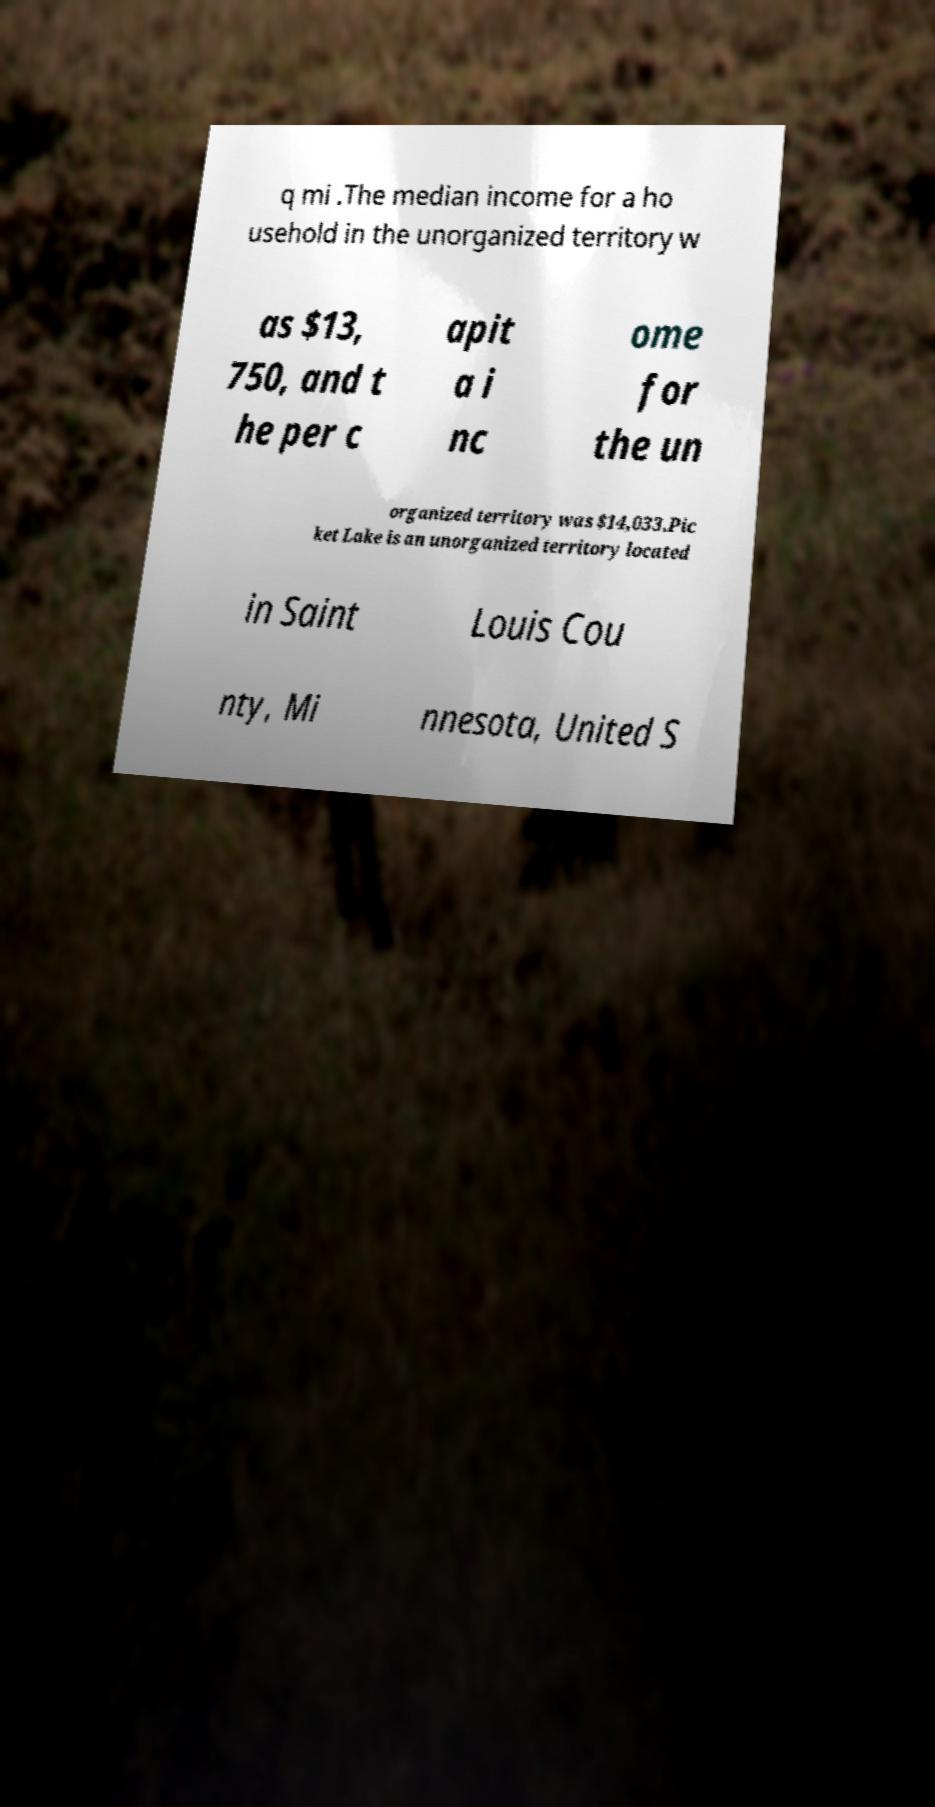I need the written content from this picture converted into text. Can you do that? q mi .The median income for a ho usehold in the unorganized territory w as $13, 750, and t he per c apit a i nc ome for the un organized territory was $14,033.Pic ket Lake is an unorganized territory located in Saint Louis Cou nty, Mi nnesota, United S 